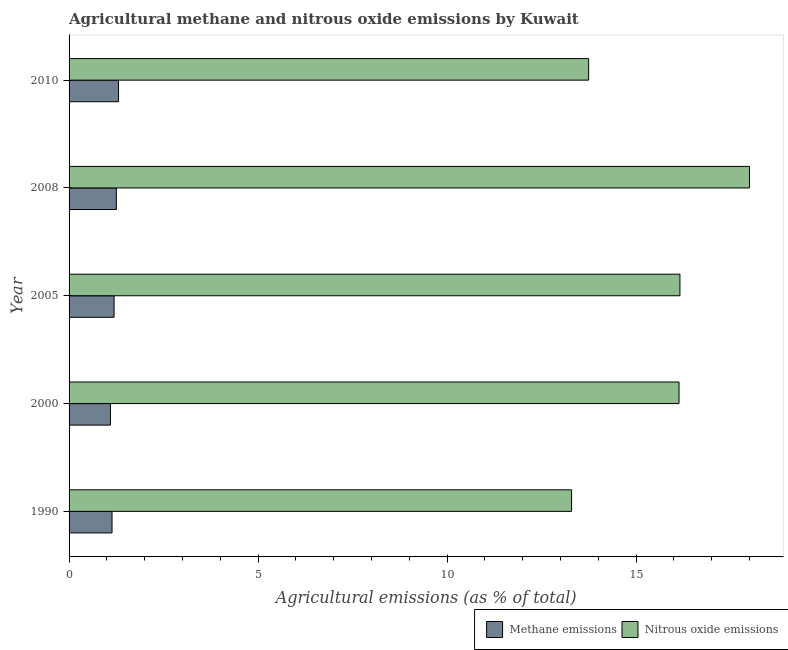How many different coloured bars are there?
Offer a very short reply. 2. How many bars are there on the 1st tick from the bottom?
Ensure brevity in your answer.  2. What is the label of the 3rd group of bars from the top?
Provide a succinct answer. 2005. What is the amount of methane emissions in 2008?
Offer a terse response. 1.25. Across all years, what is the maximum amount of methane emissions?
Offer a very short reply. 1.31. Across all years, what is the minimum amount of nitrous oxide emissions?
Your answer should be very brief. 13.29. In which year was the amount of nitrous oxide emissions minimum?
Offer a terse response. 1990. What is the total amount of methane emissions in the graph?
Your answer should be compact. 5.98. What is the difference between the amount of nitrous oxide emissions in 1990 and that in 2008?
Offer a terse response. -4.71. What is the difference between the amount of methane emissions in 2000 and the amount of nitrous oxide emissions in 2008?
Provide a short and direct response. -16.9. What is the average amount of nitrous oxide emissions per year?
Keep it short and to the point. 15.47. In the year 2000, what is the difference between the amount of nitrous oxide emissions and amount of methane emissions?
Your response must be concise. 15.04. What is the ratio of the amount of methane emissions in 1990 to that in 2000?
Your response must be concise. 1.04. Is the amount of methane emissions in 2008 less than that in 2010?
Keep it short and to the point. Yes. Is the difference between the amount of nitrous oxide emissions in 2008 and 2010 greater than the difference between the amount of methane emissions in 2008 and 2010?
Your answer should be compact. Yes. What is the difference between the highest and the second highest amount of nitrous oxide emissions?
Give a very brief answer. 1.84. What is the difference between the highest and the lowest amount of methane emissions?
Provide a short and direct response. 0.21. Is the sum of the amount of nitrous oxide emissions in 2000 and 2010 greater than the maximum amount of methane emissions across all years?
Provide a succinct answer. Yes. What does the 1st bar from the top in 2000 represents?
Keep it short and to the point. Nitrous oxide emissions. What does the 2nd bar from the bottom in 2008 represents?
Keep it short and to the point. Nitrous oxide emissions. How many bars are there?
Provide a short and direct response. 10. Are all the bars in the graph horizontal?
Make the answer very short. Yes. How many years are there in the graph?
Make the answer very short. 5. What is the difference between two consecutive major ticks on the X-axis?
Your answer should be very brief. 5. Does the graph contain any zero values?
Give a very brief answer. No. How are the legend labels stacked?
Make the answer very short. Horizontal. What is the title of the graph?
Give a very brief answer. Agricultural methane and nitrous oxide emissions by Kuwait. Does "Education" appear as one of the legend labels in the graph?
Your answer should be compact. No. What is the label or title of the X-axis?
Provide a succinct answer. Agricultural emissions (as % of total). What is the label or title of the Y-axis?
Provide a short and direct response. Year. What is the Agricultural emissions (as % of total) in Methane emissions in 1990?
Your response must be concise. 1.14. What is the Agricultural emissions (as % of total) of Nitrous oxide emissions in 1990?
Ensure brevity in your answer.  13.29. What is the Agricultural emissions (as % of total) of Methane emissions in 2000?
Keep it short and to the point. 1.09. What is the Agricultural emissions (as % of total) in Nitrous oxide emissions in 2000?
Your answer should be very brief. 16.13. What is the Agricultural emissions (as % of total) of Methane emissions in 2005?
Give a very brief answer. 1.19. What is the Agricultural emissions (as % of total) in Nitrous oxide emissions in 2005?
Your answer should be compact. 16.16. What is the Agricultural emissions (as % of total) of Methane emissions in 2008?
Provide a short and direct response. 1.25. What is the Agricultural emissions (as % of total) of Nitrous oxide emissions in 2008?
Your answer should be very brief. 18. What is the Agricultural emissions (as % of total) of Methane emissions in 2010?
Offer a very short reply. 1.31. What is the Agricultural emissions (as % of total) of Nitrous oxide emissions in 2010?
Your answer should be very brief. 13.74. Across all years, what is the maximum Agricultural emissions (as % of total) in Methane emissions?
Give a very brief answer. 1.31. Across all years, what is the maximum Agricultural emissions (as % of total) of Nitrous oxide emissions?
Your answer should be compact. 18. Across all years, what is the minimum Agricultural emissions (as % of total) in Methane emissions?
Offer a very short reply. 1.09. Across all years, what is the minimum Agricultural emissions (as % of total) in Nitrous oxide emissions?
Your answer should be compact. 13.29. What is the total Agricultural emissions (as % of total) in Methane emissions in the graph?
Your answer should be compact. 5.98. What is the total Agricultural emissions (as % of total) of Nitrous oxide emissions in the graph?
Provide a short and direct response. 77.33. What is the difference between the Agricultural emissions (as % of total) in Methane emissions in 1990 and that in 2000?
Your answer should be compact. 0.04. What is the difference between the Agricultural emissions (as % of total) of Nitrous oxide emissions in 1990 and that in 2000?
Provide a succinct answer. -2.84. What is the difference between the Agricultural emissions (as % of total) in Methane emissions in 1990 and that in 2005?
Offer a terse response. -0.05. What is the difference between the Agricultural emissions (as % of total) of Nitrous oxide emissions in 1990 and that in 2005?
Keep it short and to the point. -2.87. What is the difference between the Agricultural emissions (as % of total) of Methane emissions in 1990 and that in 2008?
Provide a short and direct response. -0.11. What is the difference between the Agricultural emissions (as % of total) in Nitrous oxide emissions in 1990 and that in 2008?
Provide a succinct answer. -4.71. What is the difference between the Agricultural emissions (as % of total) in Methane emissions in 1990 and that in 2010?
Your answer should be very brief. -0.17. What is the difference between the Agricultural emissions (as % of total) of Nitrous oxide emissions in 1990 and that in 2010?
Offer a terse response. -0.45. What is the difference between the Agricultural emissions (as % of total) of Methane emissions in 2000 and that in 2005?
Make the answer very short. -0.1. What is the difference between the Agricultural emissions (as % of total) of Nitrous oxide emissions in 2000 and that in 2005?
Keep it short and to the point. -0.02. What is the difference between the Agricultural emissions (as % of total) in Methane emissions in 2000 and that in 2008?
Provide a succinct answer. -0.16. What is the difference between the Agricultural emissions (as % of total) of Nitrous oxide emissions in 2000 and that in 2008?
Your answer should be very brief. -1.86. What is the difference between the Agricultural emissions (as % of total) of Methane emissions in 2000 and that in 2010?
Your response must be concise. -0.21. What is the difference between the Agricultural emissions (as % of total) in Nitrous oxide emissions in 2000 and that in 2010?
Provide a short and direct response. 2.39. What is the difference between the Agricultural emissions (as % of total) in Methane emissions in 2005 and that in 2008?
Offer a very short reply. -0.06. What is the difference between the Agricultural emissions (as % of total) in Nitrous oxide emissions in 2005 and that in 2008?
Keep it short and to the point. -1.84. What is the difference between the Agricultural emissions (as % of total) in Methane emissions in 2005 and that in 2010?
Your answer should be compact. -0.12. What is the difference between the Agricultural emissions (as % of total) in Nitrous oxide emissions in 2005 and that in 2010?
Your response must be concise. 2.42. What is the difference between the Agricultural emissions (as % of total) in Methane emissions in 2008 and that in 2010?
Keep it short and to the point. -0.06. What is the difference between the Agricultural emissions (as % of total) of Nitrous oxide emissions in 2008 and that in 2010?
Provide a short and direct response. 4.25. What is the difference between the Agricultural emissions (as % of total) in Methane emissions in 1990 and the Agricultural emissions (as % of total) in Nitrous oxide emissions in 2000?
Your response must be concise. -15. What is the difference between the Agricultural emissions (as % of total) in Methane emissions in 1990 and the Agricultural emissions (as % of total) in Nitrous oxide emissions in 2005?
Your answer should be very brief. -15.02. What is the difference between the Agricultural emissions (as % of total) in Methane emissions in 1990 and the Agricultural emissions (as % of total) in Nitrous oxide emissions in 2008?
Your answer should be very brief. -16.86. What is the difference between the Agricultural emissions (as % of total) in Methane emissions in 1990 and the Agricultural emissions (as % of total) in Nitrous oxide emissions in 2010?
Keep it short and to the point. -12.61. What is the difference between the Agricultural emissions (as % of total) of Methane emissions in 2000 and the Agricultural emissions (as % of total) of Nitrous oxide emissions in 2005?
Ensure brevity in your answer.  -15.06. What is the difference between the Agricultural emissions (as % of total) in Methane emissions in 2000 and the Agricultural emissions (as % of total) in Nitrous oxide emissions in 2008?
Ensure brevity in your answer.  -16.9. What is the difference between the Agricultural emissions (as % of total) in Methane emissions in 2000 and the Agricultural emissions (as % of total) in Nitrous oxide emissions in 2010?
Offer a very short reply. -12.65. What is the difference between the Agricultural emissions (as % of total) in Methane emissions in 2005 and the Agricultural emissions (as % of total) in Nitrous oxide emissions in 2008?
Your answer should be compact. -16.81. What is the difference between the Agricultural emissions (as % of total) in Methane emissions in 2005 and the Agricultural emissions (as % of total) in Nitrous oxide emissions in 2010?
Offer a terse response. -12.55. What is the difference between the Agricultural emissions (as % of total) in Methane emissions in 2008 and the Agricultural emissions (as % of total) in Nitrous oxide emissions in 2010?
Your answer should be very brief. -12.49. What is the average Agricultural emissions (as % of total) of Methane emissions per year?
Offer a very short reply. 1.2. What is the average Agricultural emissions (as % of total) of Nitrous oxide emissions per year?
Your response must be concise. 15.47. In the year 1990, what is the difference between the Agricultural emissions (as % of total) in Methane emissions and Agricultural emissions (as % of total) in Nitrous oxide emissions?
Keep it short and to the point. -12.16. In the year 2000, what is the difference between the Agricultural emissions (as % of total) in Methane emissions and Agricultural emissions (as % of total) in Nitrous oxide emissions?
Provide a short and direct response. -15.04. In the year 2005, what is the difference between the Agricultural emissions (as % of total) of Methane emissions and Agricultural emissions (as % of total) of Nitrous oxide emissions?
Your response must be concise. -14.97. In the year 2008, what is the difference between the Agricultural emissions (as % of total) of Methane emissions and Agricultural emissions (as % of total) of Nitrous oxide emissions?
Offer a terse response. -16.75. In the year 2010, what is the difference between the Agricultural emissions (as % of total) of Methane emissions and Agricultural emissions (as % of total) of Nitrous oxide emissions?
Ensure brevity in your answer.  -12.44. What is the ratio of the Agricultural emissions (as % of total) of Nitrous oxide emissions in 1990 to that in 2000?
Your response must be concise. 0.82. What is the ratio of the Agricultural emissions (as % of total) of Methane emissions in 1990 to that in 2005?
Your answer should be compact. 0.95. What is the ratio of the Agricultural emissions (as % of total) in Nitrous oxide emissions in 1990 to that in 2005?
Your response must be concise. 0.82. What is the ratio of the Agricultural emissions (as % of total) in Methane emissions in 1990 to that in 2008?
Your answer should be compact. 0.91. What is the ratio of the Agricultural emissions (as % of total) in Nitrous oxide emissions in 1990 to that in 2008?
Offer a very short reply. 0.74. What is the ratio of the Agricultural emissions (as % of total) in Methane emissions in 1990 to that in 2010?
Your answer should be compact. 0.87. What is the ratio of the Agricultural emissions (as % of total) in Nitrous oxide emissions in 1990 to that in 2010?
Make the answer very short. 0.97. What is the ratio of the Agricultural emissions (as % of total) in Methane emissions in 2000 to that in 2005?
Your answer should be very brief. 0.92. What is the ratio of the Agricultural emissions (as % of total) in Nitrous oxide emissions in 2000 to that in 2005?
Offer a very short reply. 1. What is the ratio of the Agricultural emissions (as % of total) in Methane emissions in 2000 to that in 2008?
Provide a short and direct response. 0.88. What is the ratio of the Agricultural emissions (as % of total) of Nitrous oxide emissions in 2000 to that in 2008?
Offer a very short reply. 0.9. What is the ratio of the Agricultural emissions (as % of total) of Methane emissions in 2000 to that in 2010?
Give a very brief answer. 0.84. What is the ratio of the Agricultural emissions (as % of total) of Nitrous oxide emissions in 2000 to that in 2010?
Offer a very short reply. 1.17. What is the ratio of the Agricultural emissions (as % of total) in Methane emissions in 2005 to that in 2008?
Your answer should be very brief. 0.95. What is the ratio of the Agricultural emissions (as % of total) of Nitrous oxide emissions in 2005 to that in 2008?
Your answer should be very brief. 0.9. What is the ratio of the Agricultural emissions (as % of total) in Methane emissions in 2005 to that in 2010?
Offer a terse response. 0.91. What is the ratio of the Agricultural emissions (as % of total) of Nitrous oxide emissions in 2005 to that in 2010?
Keep it short and to the point. 1.18. What is the ratio of the Agricultural emissions (as % of total) in Methane emissions in 2008 to that in 2010?
Ensure brevity in your answer.  0.96. What is the ratio of the Agricultural emissions (as % of total) in Nitrous oxide emissions in 2008 to that in 2010?
Make the answer very short. 1.31. What is the difference between the highest and the second highest Agricultural emissions (as % of total) in Methane emissions?
Give a very brief answer. 0.06. What is the difference between the highest and the second highest Agricultural emissions (as % of total) of Nitrous oxide emissions?
Keep it short and to the point. 1.84. What is the difference between the highest and the lowest Agricultural emissions (as % of total) of Methane emissions?
Your answer should be very brief. 0.21. What is the difference between the highest and the lowest Agricultural emissions (as % of total) in Nitrous oxide emissions?
Your answer should be very brief. 4.71. 